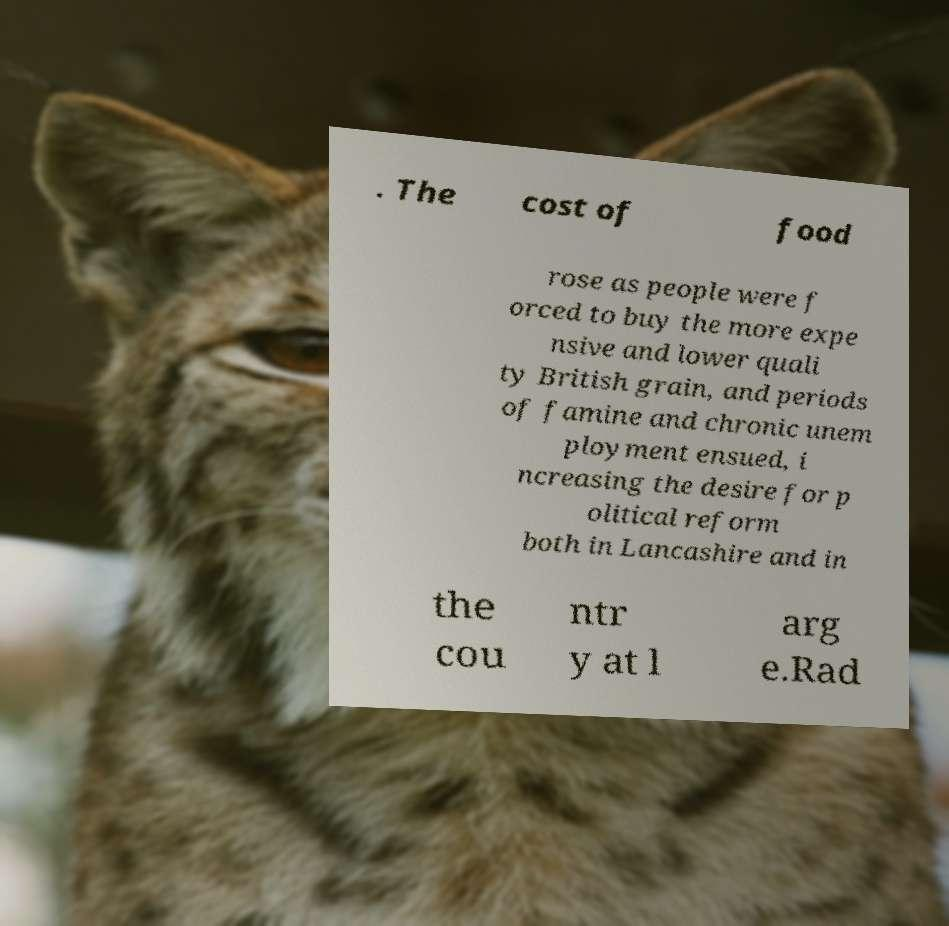I need the written content from this picture converted into text. Can you do that? . The cost of food rose as people were f orced to buy the more expe nsive and lower quali ty British grain, and periods of famine and chronic unem ployment ensued, i ncreasing the desire for p olitical reform both in Lancashire and in the cou ntr y at l arg e.Rad 